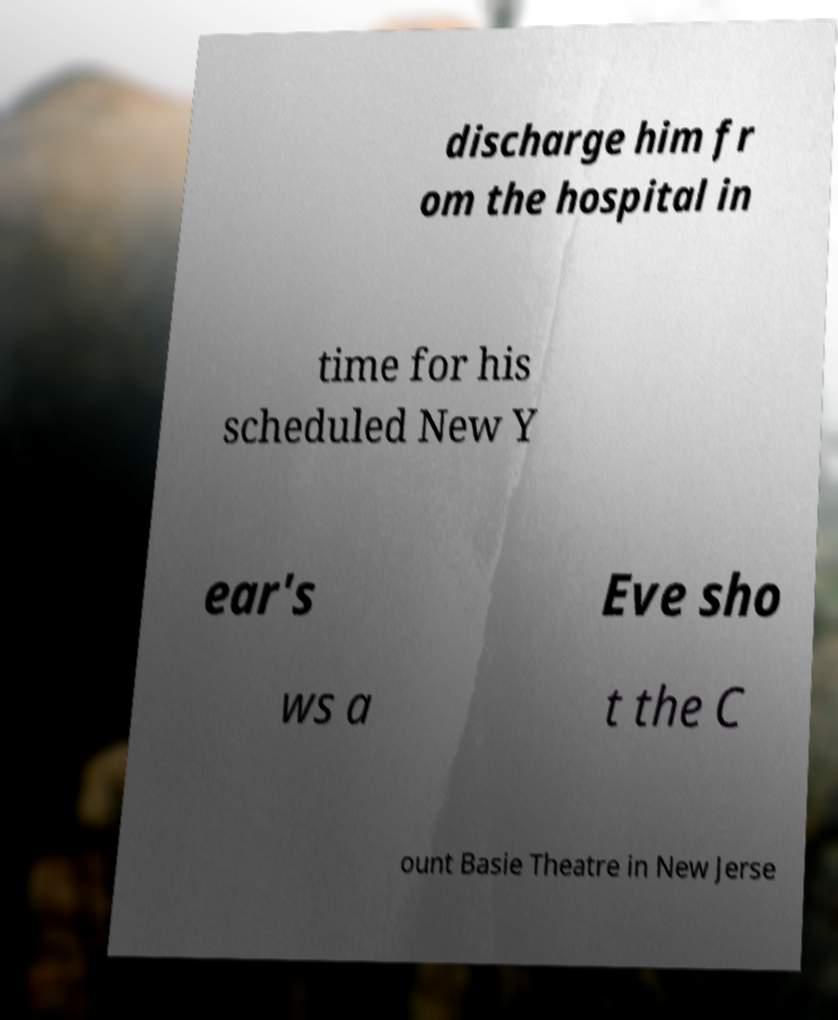Can you accurately transcribe the text from the provided image for me? discharge him fr om the hospital in time for his scheduled New Y ear's Eve sho ws a t the C ount Basie Theatre in New Jerse 